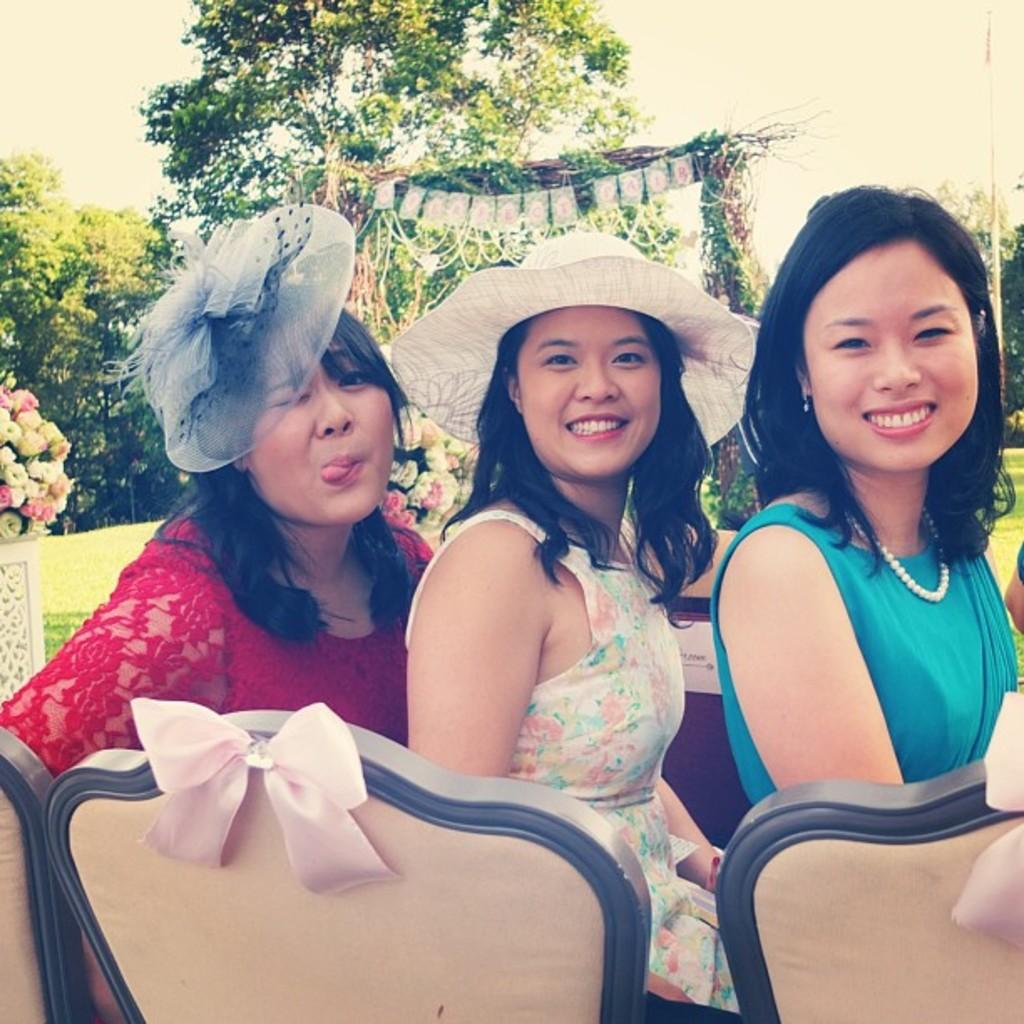How many women are in the image? There are three women in the image. What are the women doing in the image? The women are sitting on chairs. Where are the chairs located in relation to the table? The chairs are in front of a table. What can be seen in the background of the image? There are house plants, trees, and the sky visible in the background of the image. What is the setting of the image? The image is taken in a park. What type of icicle can be seen hanging from the tree in the image? There is no icicle present in the image, as it is taken in a park and the sky is visible, suggesting a warm or temperate climate. 